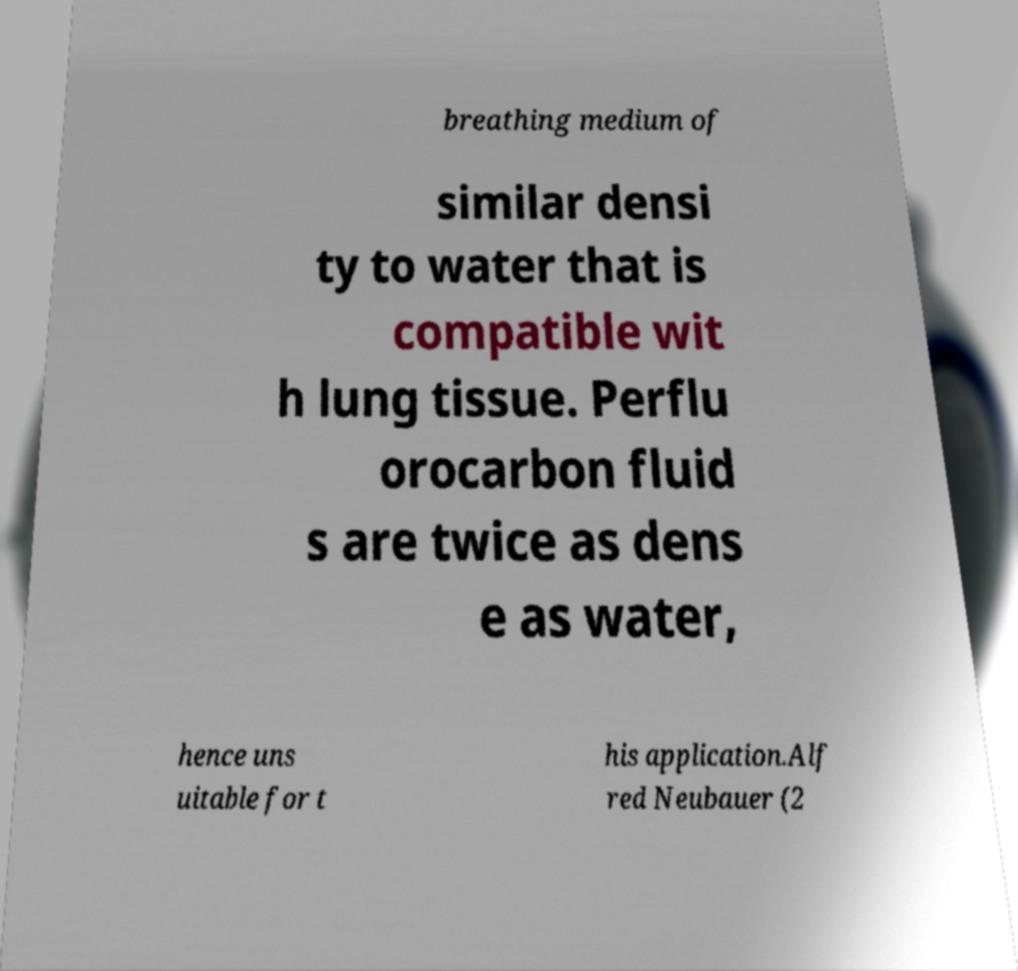I need the written content from this picture converted into text. Can you do that? breathing medium of similar densi ty to water that is compatible wit h lung tissue. Perflu orocarbon fluid s are twice as dens e as water, hence uns uitable for t his application.Alf red Neubauer (2 